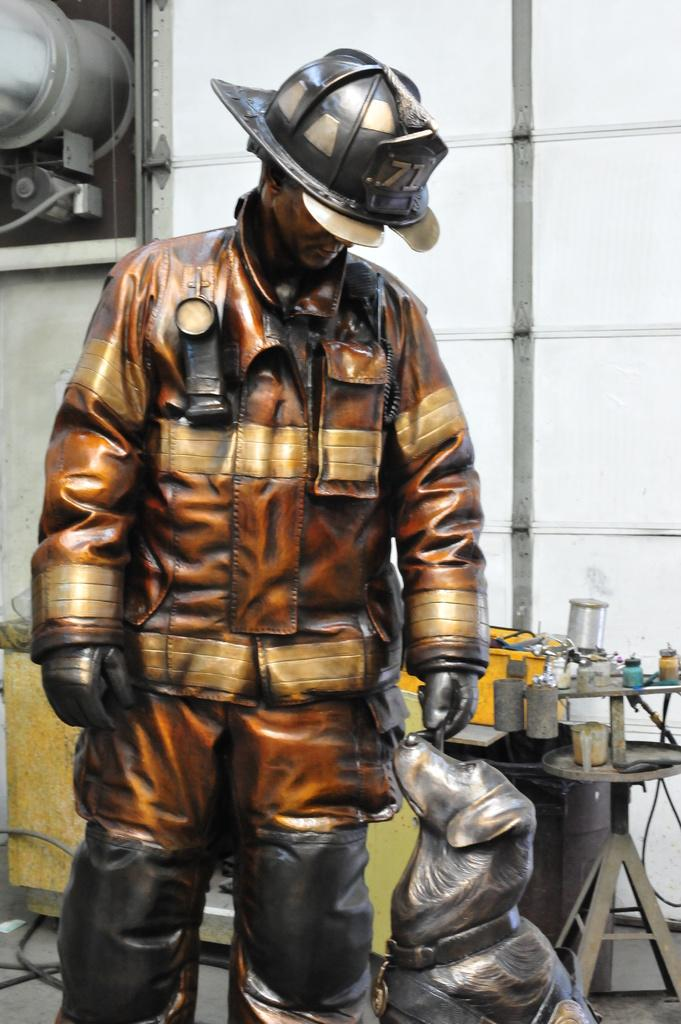What is the main subject in the image? There is a statue in the image. What can be seen in the background of the image? There is a table and a wall in the background of the image. What is placed on the table? There are things placed on the table. What is hanging on the wall? There is a frame placed on the wall. What type of chin can be seen on the statue in the image? There is no chin visible on the statue in the image, as it is not a human figure. 